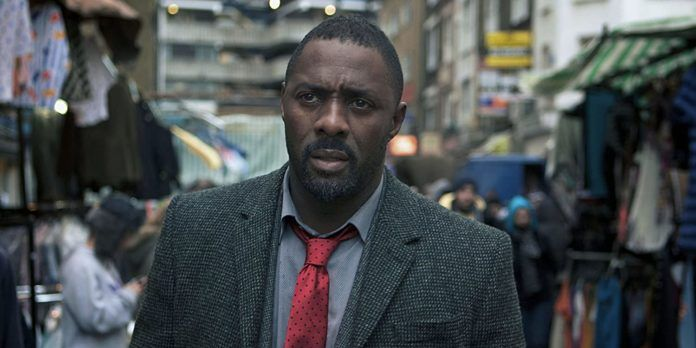Can you describe a realistic scenario where this market could be a crucial element in an investigation? In a realistic scenario, this bustling market could be the setting for a crucial undercover operation. DCI John Luther might be tracking a notorious pickpocket gang that uses the crowd to blend in and escape after their deeds. The market offers a myriad of hiding spots, from vendor booths to back alleys, making it a complex maze for law enforcement. Luther, keenly observing every detail, spots a suspicious exchange between two individuals near a clothing stall. This small detail could unravel a larger network of petty crimes linked to more heinous activities, making the market a pivotal element in the broader investigation. What kind of clues might Luther find in this market that could lead him to solve a case? In this market, Luther might discover subtle yet telling clues like a series of coded messages slipped into the pockets of clothing stalls, or witness a hurried exchange of items that appear innocuous at first glance. Perhaps he notices a recurring symbol or marking on certain goods that link back to a criminal organization. Another crucial clue could be overheard snippets of conversation that, when pieced together, reveal the time and place of a planned illegal activity. Additionally, Luther might find a discarded piece of evidence, like a note or a unique item, that connects to a suspect in his ongoing investigation.  If this picture was the cover of a mystery novel, what would the title and tagline be? Title: **Market of Shadows**
Tagline: *In the heart of the city's chaos, one detective must untangle the web of deceit hidden in plain sight.* 